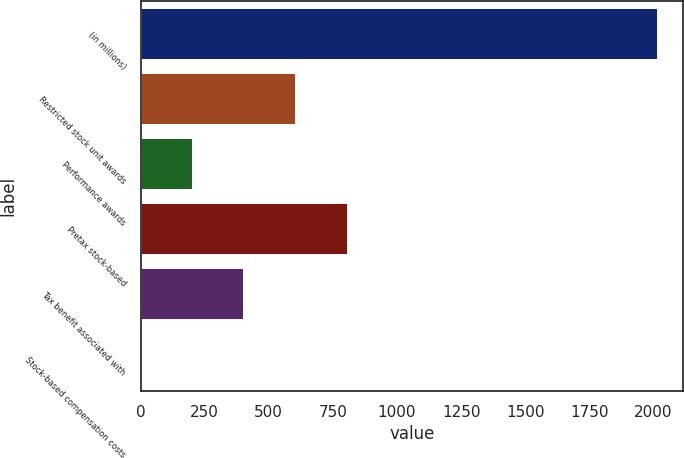<chart> <loc_0><loc_0><loc_500><loc_500><bar_chart><fcel>(in millions)<fcel>Restricted stock unit awards<fcel>Performance awards<fcel>Pretax stock-based<fcel>Tax benefit associated with<fcel>Stock-based compensation costs<nl><fcel>2016<fcel>606.2<fcel>203.4<fcel>807.6<fcel>404.8<fcel>2<nl></chart> 